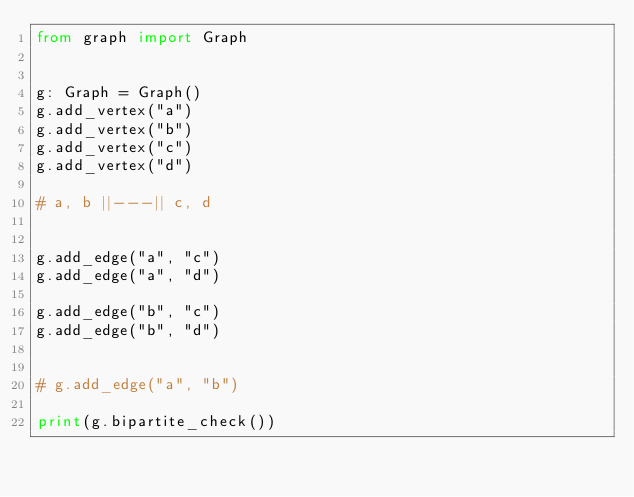<code> <loc_0><loc_0><loc_500><loc_500><_Python_>from graph import Graph


g: Graph = Graph()
g.add_vertex("a")
g.add_vertex("b")
g.add_vertex("c")
g.add_vertex("d")

# a, b ||---|| c, d


g.add_edge("a", "c")
g.add_edge("a", "d")

g.add_edge("b", "c")
g.add_edge("b", "d")


# g.add_edge("a", "b")

print(g.bipartite_check())
</code> 